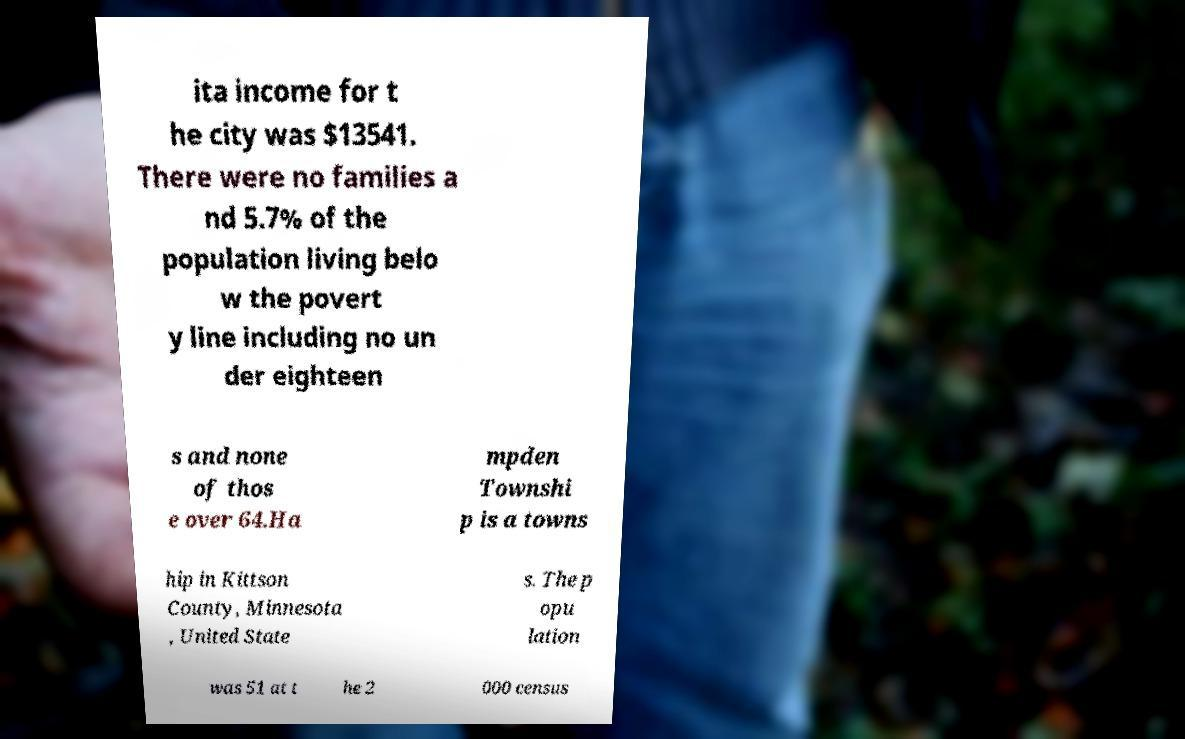Can you accurately transcribe the text from the provided image for me? ita income for t he city was $13541. There were no families a nd 5.7% of the population living belo w the povert y line including no un der eighteen s and none of thos e over 64.Ha mpden Townshi p is a towns hip in Kittson County, Minnesota , United State s. The p opu lation was 51 at t he 2 000 census 